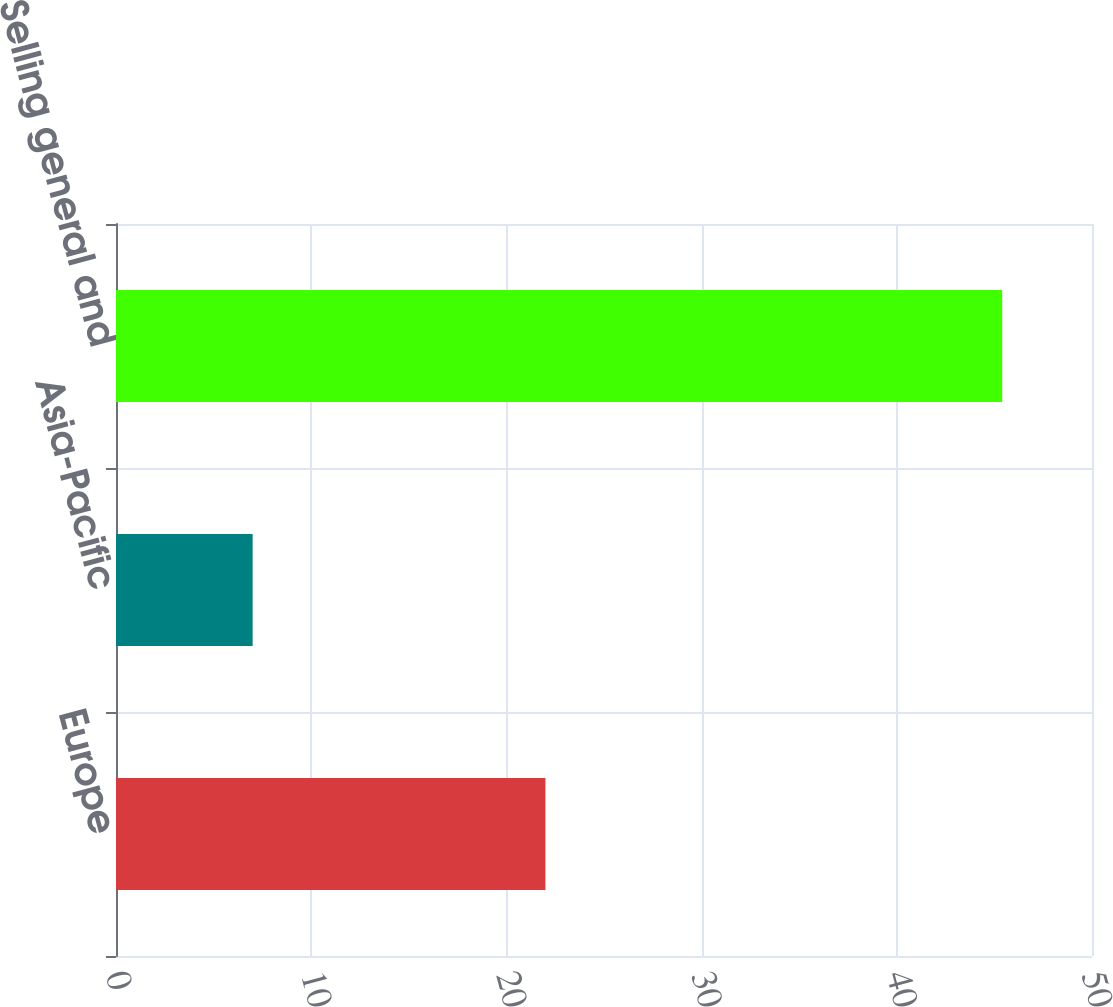Convert chart to OTSL. <chart><loc_0><loc_0><loc_500><loc_500><bar_chart><fcel>Europe<fcel>Asia-Pacific<fcel>Selling general and<nl><fcel>22<fcel>7<fcel>45.4<nl></chart> 